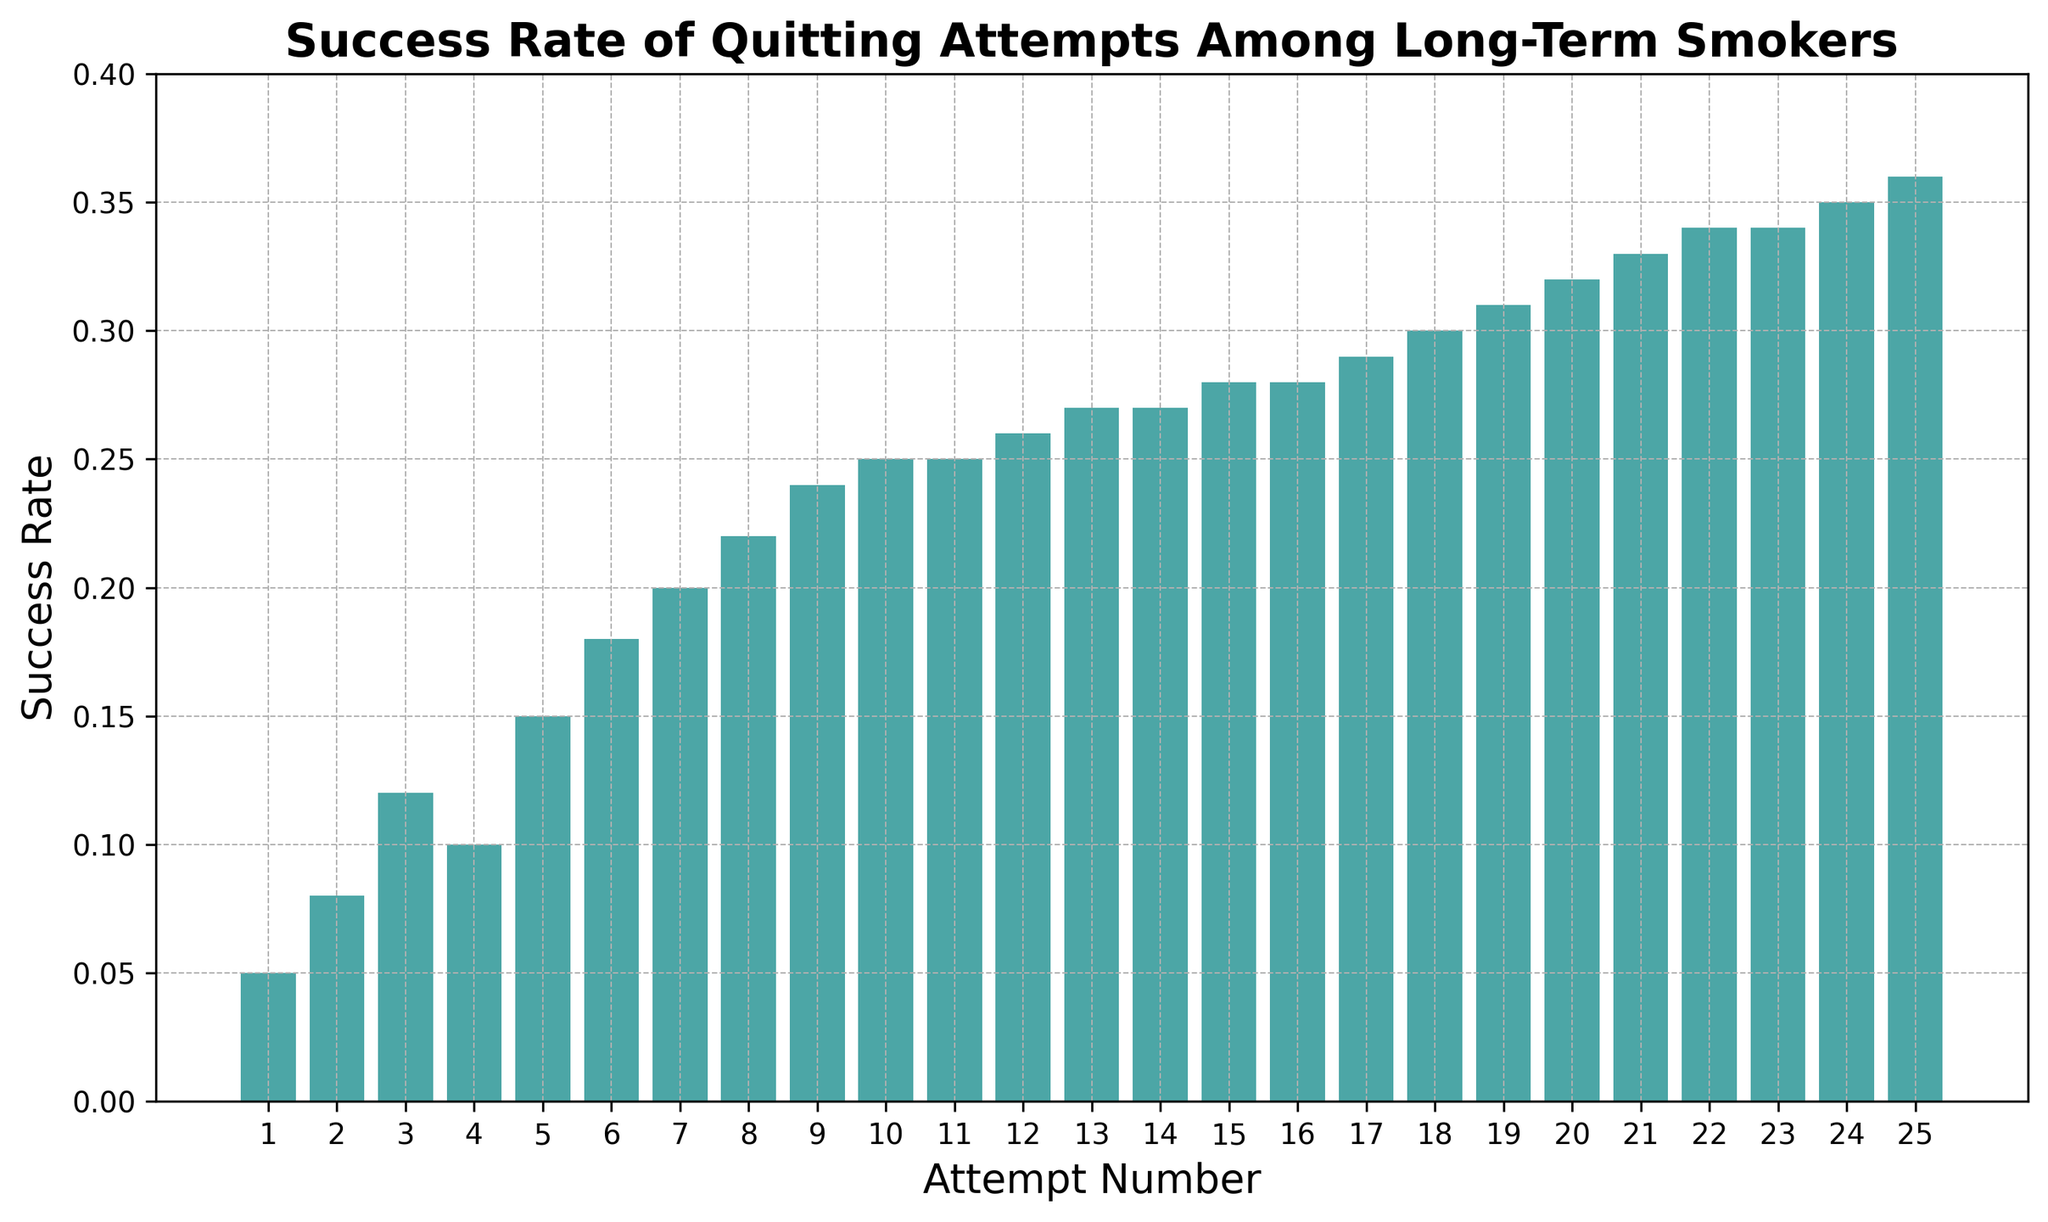What is the success rate for the first quitting attempt? Look at the bar corresponding to attempt number 1 and note the height of the bar, which represents the success rate.
Answer: 0.05 How many attempts are needed to reach a success rate of 0.3? Identify the first bar that reaches or exceeds a success rate of 0.3, and note the corresponding attempt number.
Answer: 18 What is the success rate for attempt number 10, and how does it compare to attempt number 20? Locate the bars for attempt numbers 10 and 20, compare their heights, and list the success rates.
Answer: Success rate for attempt 10 is 0.25, and for attempt 20 is 0.32; attempt 20 has a higher success rate What is the increase in the success rate from attempt number 5 to attempt number 15? Find the difference between the heights of the bars for attempt numbers 15 and 5.
Answer: The increase is 0.28 - 0.15 = 0.13 Which attempt number has the lowest success rate, and what is the rate? Scan all the bars to find the shortest bar and note its attempt number and height.
Answer: Attempt number 1 has the lowest success rate of 0.05 What is the average success rate for the first 5 attempts? Add the success rates of the first 5 attempts and divide by 5.
Answer: (0.05 + 0.08 + 0.12 + 0.10 + 0.15) / 5 = 0.10 What is the highest success rate among all the attempts? Identify the tallest bar and note its height.
Answer: 0.36 How does the success rate change between attempts 12 and 24? Observe the bars for attempts 12 and 24, and calculate the difference in their heights.
Answer: The increase is 0.35 - 0.26 = 0.09 What is the median success rate for all attempts shown? Arrange all the success rates in ascending order and find the middle value (or the average of the two middle values if the number of attempts is even).
Answer: The median success rate is 0.275 Is there a point where the success rate does not increase and remains constant? If so, between which attempts? Examine the sequence of success rates to identify any range of attempts where the height of the bars does not change.
Answer: The success rate remains constant at 0.25 between attempts 10 and 11 